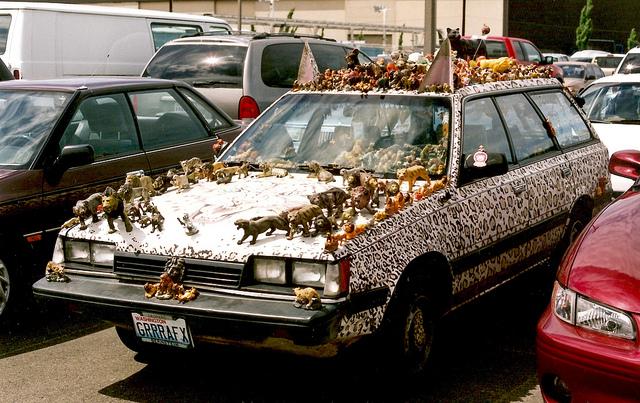What is covering this car?
Write a very short answer. Animals. Where is the unique car parked?
Give a very brief answer. Parking lot. Is this a normal looking car?
Write a very short answer. No. How many red vehicles do you see?
Quick response, please. 2. What are all the things on top of the car?
Write a very short answer. Animals. 